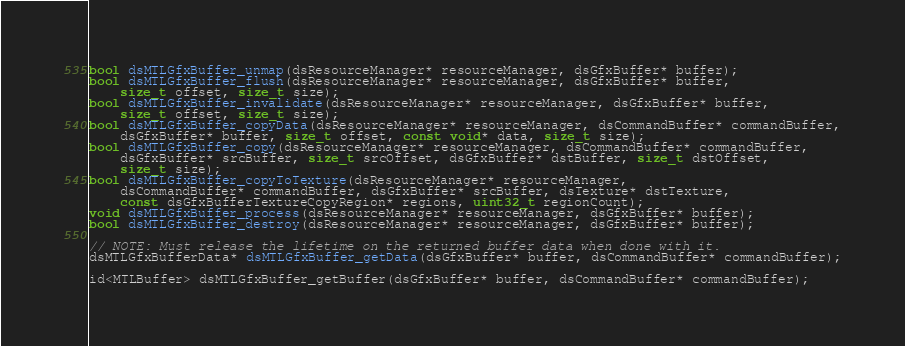Convert code to text. <code><loc_0><loc_0><loc_500><loc_500><_C_>bool dsMTLGfxBuffer_unmap(dsResourceManager* resourceManager, dsGfxBuffer* buffer);
bool dsMTLGfxBuffer_flush(dsResourceManager* resourceManager, dsGfxBuffer* buffer,
	size_t offset, size_t size);
bool dsMTLGfxBuffer_invalidate(dsResourceManager* resourceManager, dsGfxBuffer* buffer,
	size_t offset, size_t size);
bool dsMTLGfxBuffer_copyData(dsResourceManager* resourceManager, dsCommandBuffer* commandBuffer,
	dsGfxBuffer* buffer, size_t offset, const void* data, size_t size);
bool dsMTLGfxBuffer_copy(dsResourceManager* resourceManager, dsCommandBuffer* commandBuffer,
	dsGfxBuffer* srcBuffer, size_t srcOffset, dsGfxBuffer* dstBuffer, size_t dstOffset,
	size_t size);
bool dsMTLGfxBuffer_copyToTexture(dsResourceManager* resourceManager,
	dsCommandBuffer* commandBuffer, dsGfxBuffer* srcBuffer, dsTexture* dstTexture,
	const dsGfxBufferTextureCopyRegion* regions, uint32_t regionCount);
void dsMTLGfxBuffer_process(dsResourceManager* resourceManager, dsGfxBuffer* buffer);
bool dsMTLGfxBuffer_destroy(dsResourceManager* resourceManager, dsGfxBuffer* buffer);

// NOTE: Must release the lifetime on the returned buffer data when done with it.
dsMTLGfxBufferData* dsMTLGfxBuffer_getData(dsGfxBuffer* buffer, dsCommandBuffer* commandBuffer);

id<MTLBuffer> dsMTLGfxBuffer_getBuffer(dsGfxBuffer* buffer, dsCommandBuffer* commandBuffer);
</code> 